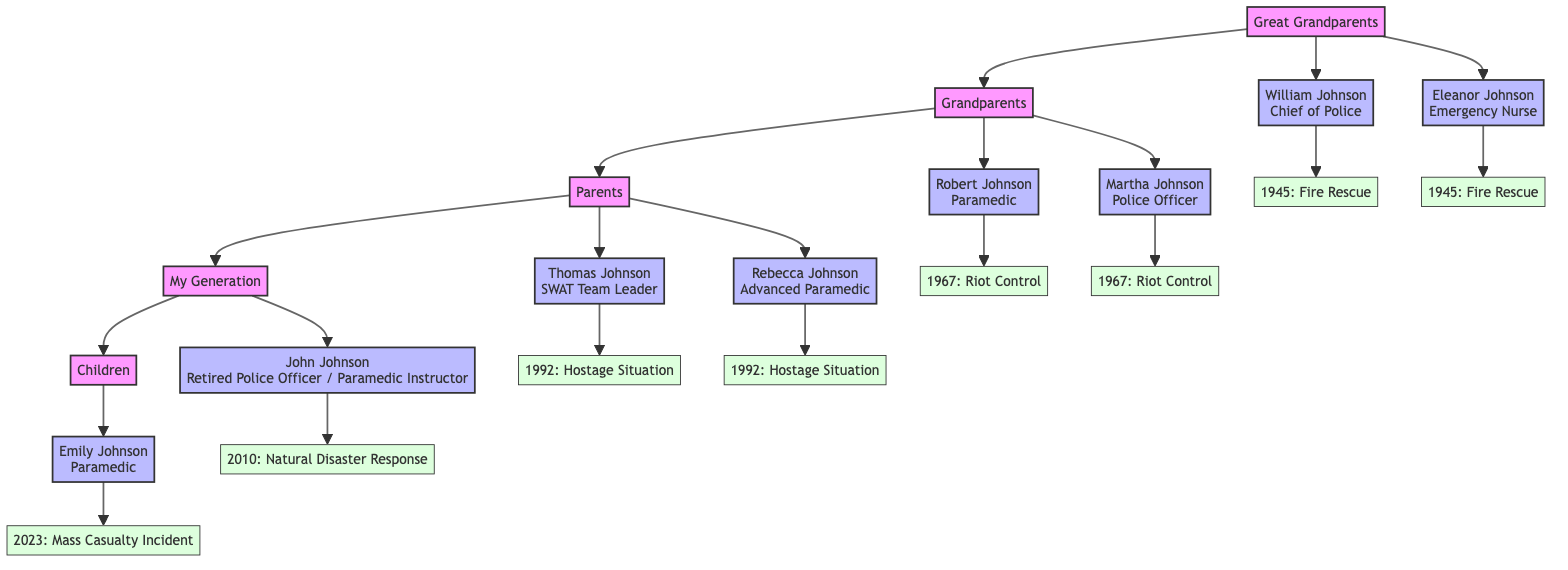What was the key incident for William Johnson? In the diagram, the critical incident associated with William Johnson is labeled "Fire Rescue" and the specific date noted is "1945-06-13." The description explains that he led the evacuation during a massive fire.
Answer: Fire Rescue How many generations are represented in the family tree? By counting the distinct groups in the diagram, we identify five generations: Great Grandparents, Grandparents, Parents, My Generation, and Children, leading to a total of five generations.
Answer: 5 Who served as a police officer during the 1967 riot? By examining the Grandparents' generation, we can see that Martha Johnson is listed as a police officer and is connected to the 1967 riot incident labeled "Riot Control."
Answer: Martha Johnson What role did John Johnson play during Hurricane Igor? The diagram shows John Johnson in My Generation, with a critical incident that describes him coordinating emergency response during Hurricane Igor, thus indicating his role was as a coordinator.
Answer: Coordinator Which generation does Emily Johnson belong to? In the family tree, Emily Johnson is noted in the Children generation. This can be confirmed by the diagram layout that connects her directly under My Generation.
Answer: Children What incident is associated with the date 1992-05-01? The diagram shows both Thomas Johnson and Rebecca Johnson involved in the same hostage situation incident, thereby linking the date "1992-05-01" with the described "Hostage Situation."
Answer: Hostage Situation How many members are involved in the Great Grandparents generation? By looking at the members listed under Great Grandparents, we find two individuals, William Johnson and Eleanor Johnson, thus confirming the total count.
Answer: 2 What type of critical incident did Robert Johnson respond to? Inspecting the critical incident associated with Robert Johnson in the Grandparents generation, we find that it is labeled "Riot Control," indicating the type of emergency he handled.
Answer: Riot Control Who provided medical care at the fire rescue in 1945? The incident description connected to Eleanor Johnson reveals that she was an Emergency Nurse who provided on-site medical care to fire victims during the fire rescue on June 13, 1945.
Answer: Eleanor Johnson 